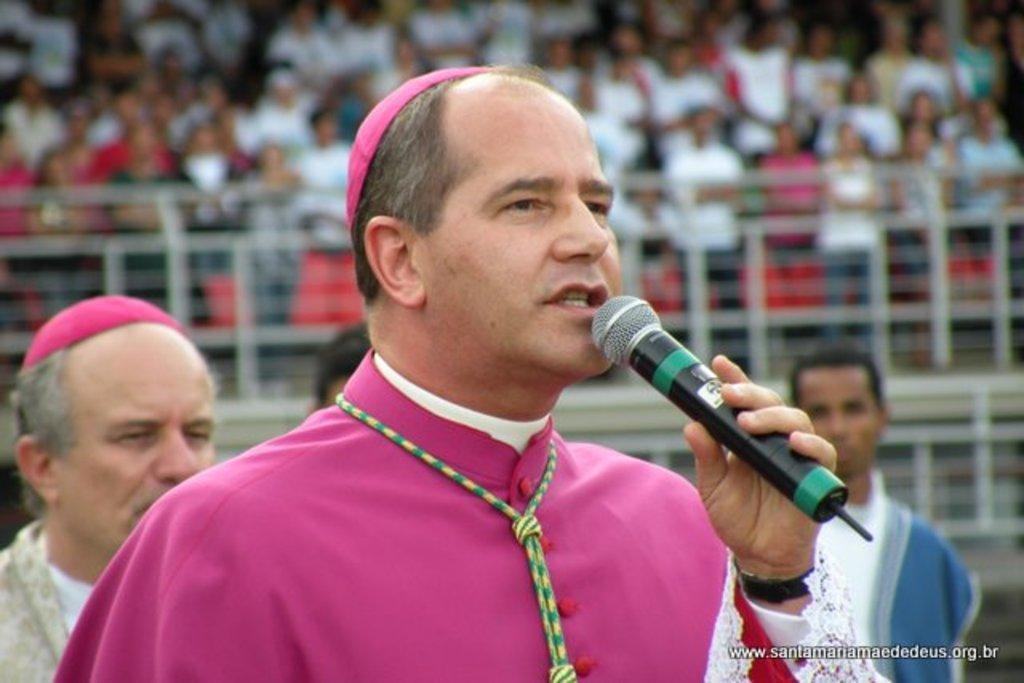Please provide a concise description of this image. In this image we can see people standing and one of them is holding mic in the hand. 